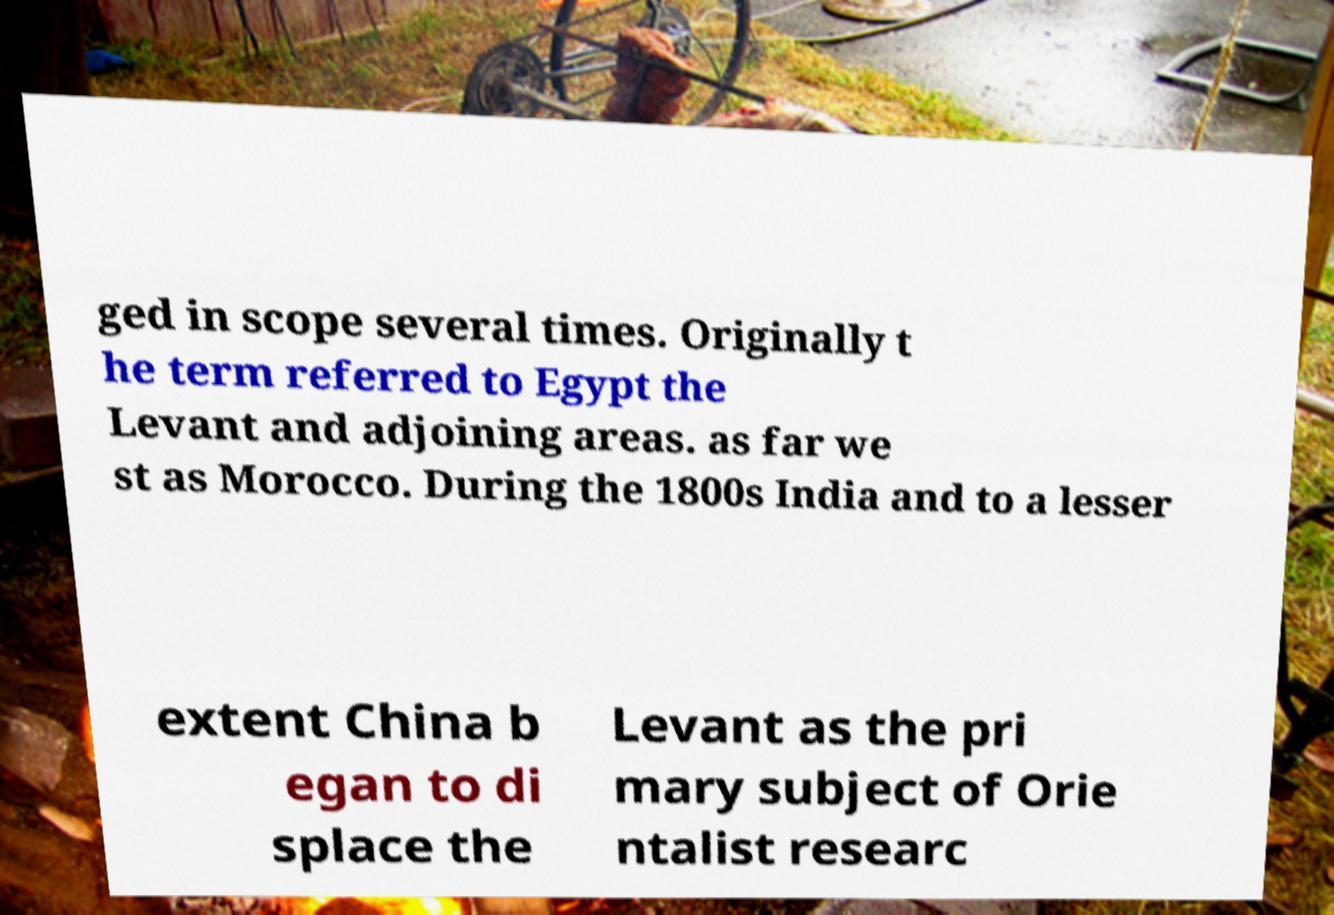Can you accurately transcribe the text from the provided image for me? ged in scope several times. Originally t he term referred to Egypt the Levant and adjoining areas. as far we st as Morocco. During the 1800s India and to a lesser extent China b egan to di splace the Levant as the pri mary subject of Orie ntalist researc 